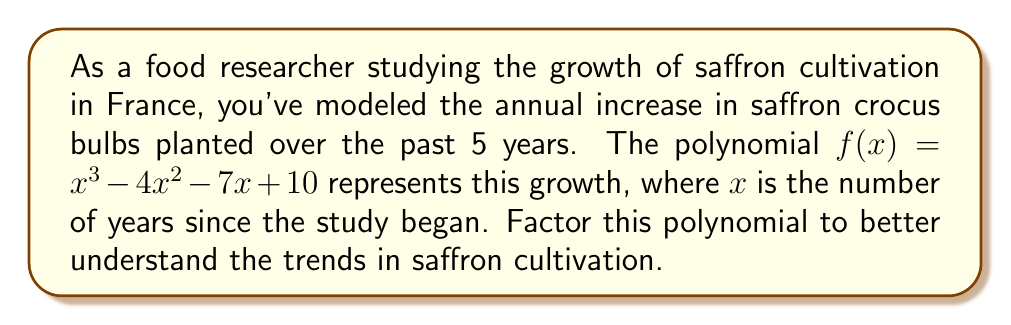Provide a solution to this math problem. To factor this polynomial, we'll follow these steps:

1) First, let's check if there are any rational roots using the rational root theorem. The possible rational roots are the factors of the constant term: ±1, ±2, ±5, ±10.

2) Testing these values, we find that $f(1) = 0$. So $(x-1)$ is a factor.

3) We can use polynomial long division to divide $f(x)$ by $(x-1)$:

   $$\frac{x^3 - 4x^2 - 7x + 10}{x - 1} = x^2 - 3x - 10$$

4) Now we need to factor the quadratic $x^2 - 3x - 10$. We can do this by finding two numbers that multiply to give -10 and add to give -3. These numbers are -5 and 2.

5) So, $x^2 - 3x - 10 = (x-5)(x+2)$

6) Combining all factors, we get:

   $f(x) = (x-1)(x-5)(x+2)$

This factorization reveals that the growth rate has three key points: when $x=1$, $x=5$, and $x=-2$. The last one is not relevant to our timeframe, but the first two indicate significant changes in the growth pattern at 1 and 5 years into the study.
Answer: $f(x) = (x-1)(x-5)(x+2)$ 